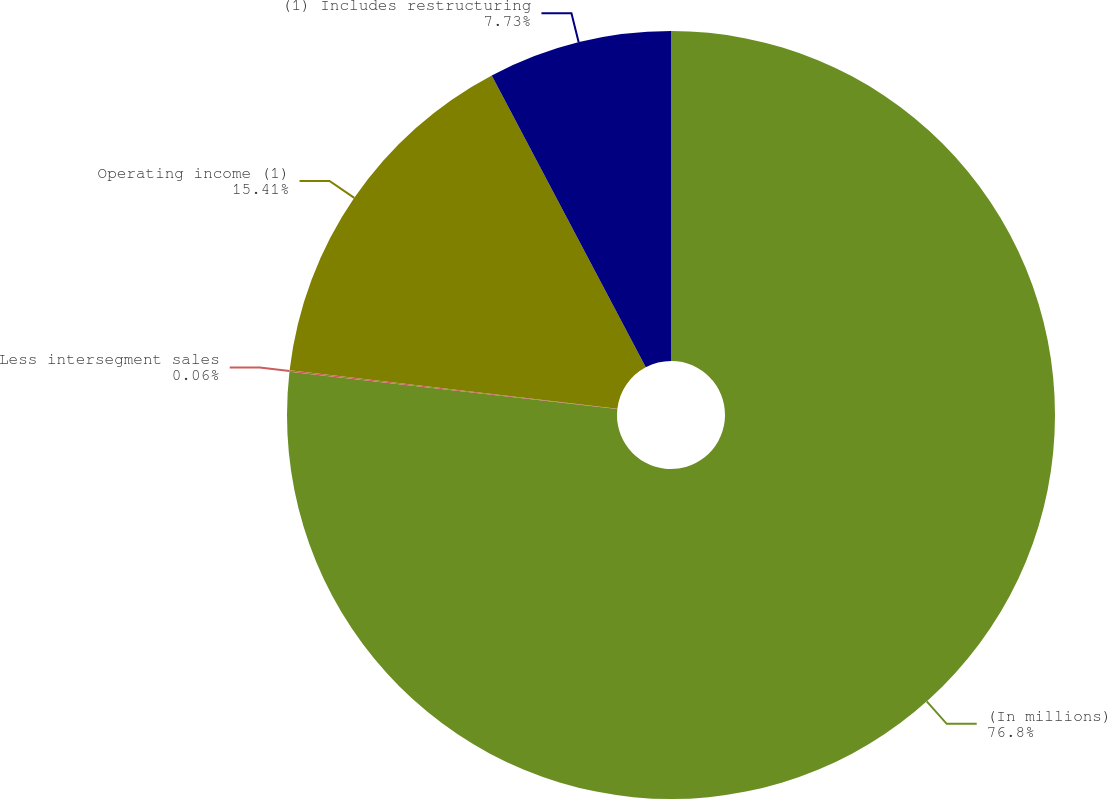Convert chart. <chart><loc_0><loc_0><loc_500><loc_500><pie_chart><fcel>(In millions)<fcel>Less intersegment sales<fcel>Operating income (1)<fcel>(1) Includes restructuring<nl><fcel>76.8%<fcel>0.06%<fcel>15.41%<fcel>7.73%<nl></chart> 